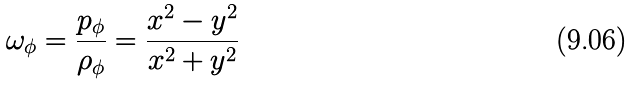<formula> <loc_0><loc_0><loc_500><loc_500>\omega _ { \phi } = \frac { p _ { \phi } } { \rho _ { \phi } } = \frac { x ^ { 2 } - y ^ { 2 } } { x ^ { 2 } + y ^ { 2 } }</formula> 